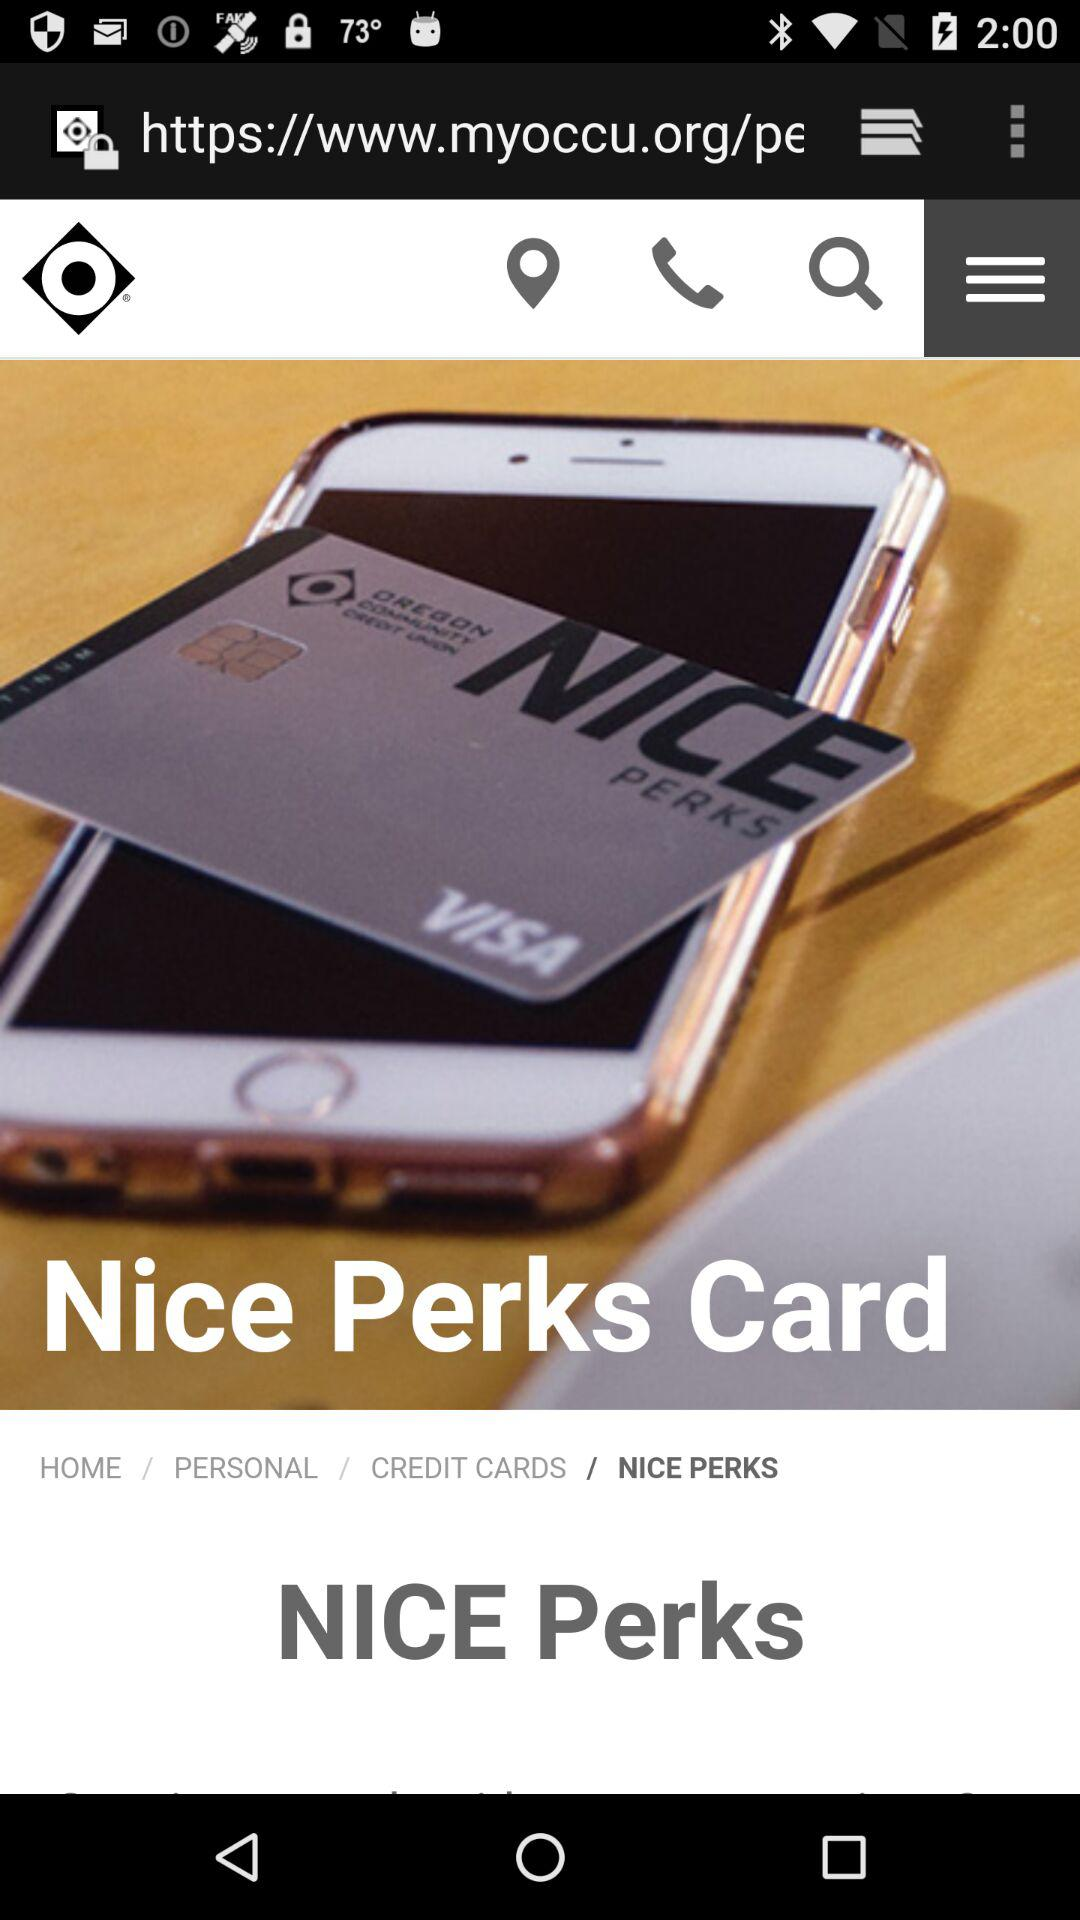How many surah are accumulated? The accumulated surah are 21. 